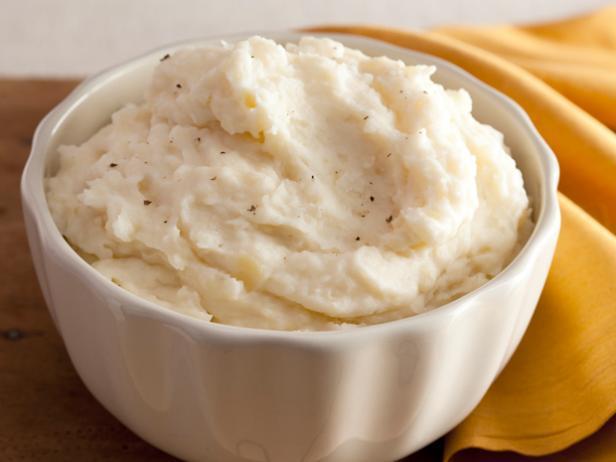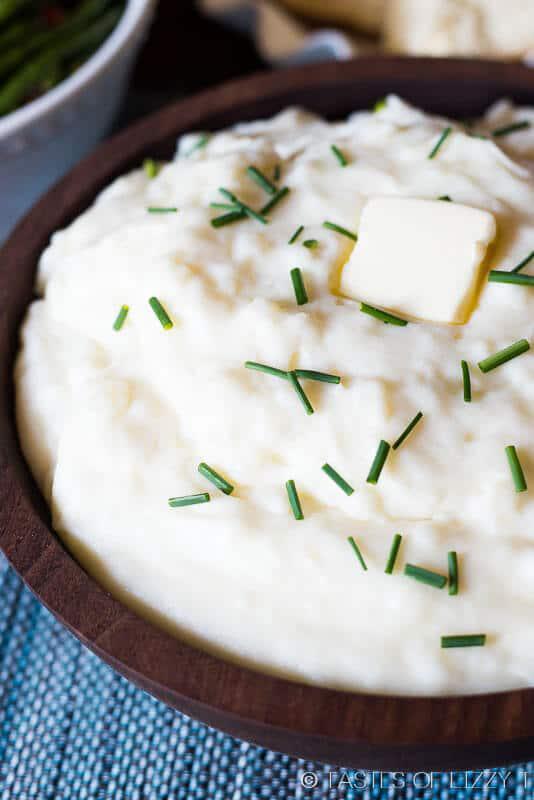The first image is the image on the left, the second image is the image on the right. Assess this claim about the two images: "An unmelted pat of butter sits in the dish in one of the images.". Correct or not? Answer yes or no. Yes. The first image is the image on the left, the second image is the image on the right. Assess this claim about the two images: "An image contains mashed potatoes with a spoon inside it.". Correct or not? Answer yes or no. No. 